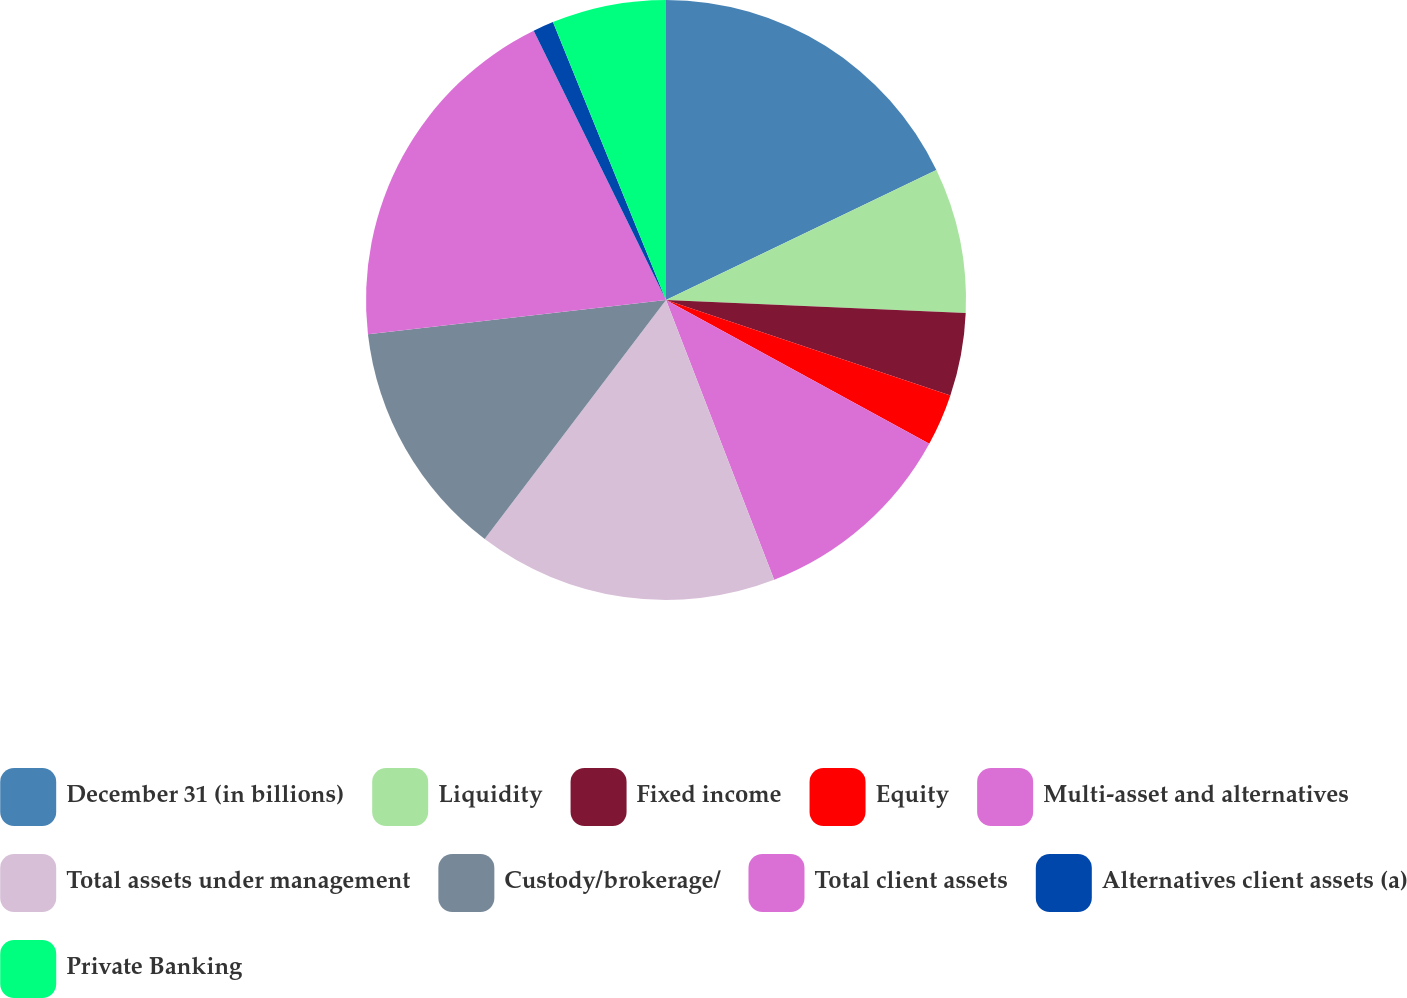<chart> <loc_0><loc_0><loc_500><loc_500><pie_chart><fcel>December 31 (in billions)<fcel>Liquidity<fcel>Fixed income<fcel>Equity<fcel>Multi-asset and alternatives<fcel>Total assets under management<fcel>Custody/brokerage/<fcel>Total client assets<fcel>Alternatives client assets (a)<fcel>Private Banking<nl><fcel>17.87%<fcel>7.82%<fcel>4.47%<fcel>2.8%<fcel>11.17%<fcel>16.2%<fcel>12.85%<fcel>19.55%<fcel>1.12%<fcel>6.15%<nl></chart> 